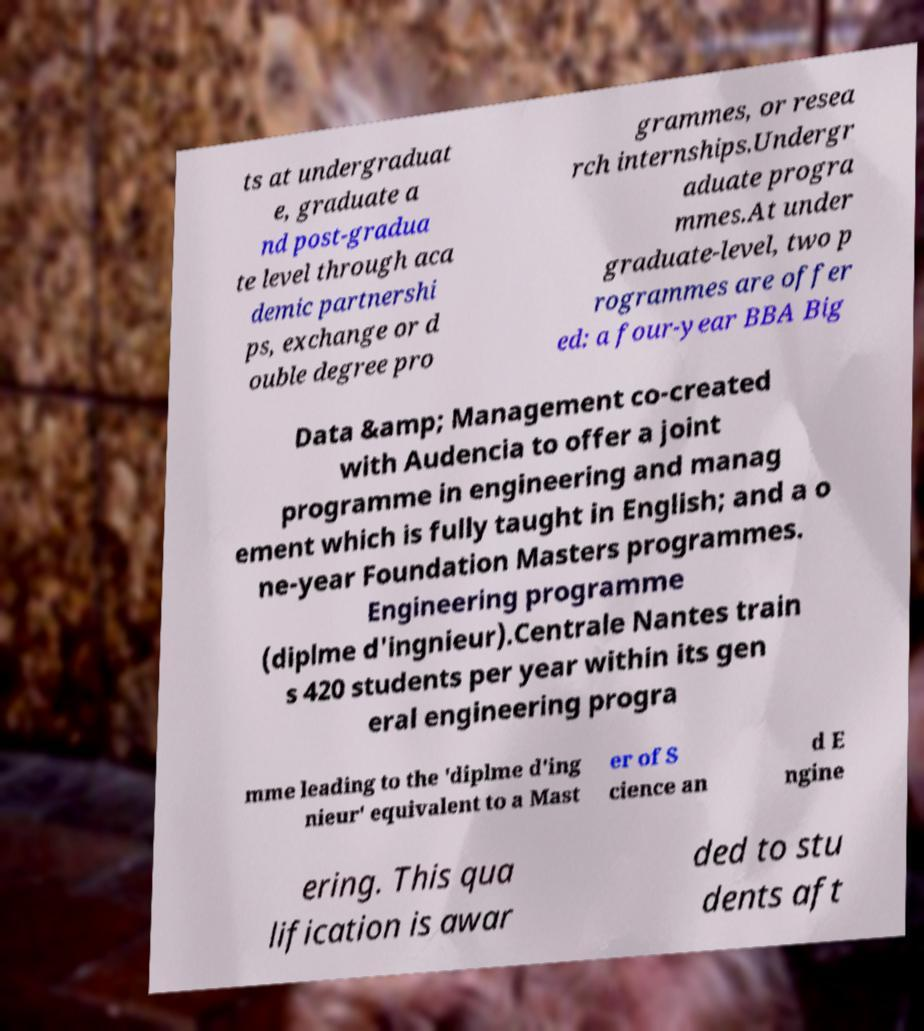Please read and relay the text visible in this image. What does it say? ts at undergraduat e, graduate a nd post-gradua te level through aca demic partnershi ps, exchange or d ouble degree pro grammes, or resea rch internships.Undergr aduate progra mmes.At under graduate-level, two p rogrammes are offer ed: a four-year BBA Big Data &amp; Management co-created with Audencia to offer a joint programme in engineering and manag ement which is fully taught in English; and a o ne-year Foundation Masters programmes. Engineering programme (diplme d'ingnieur).Centrale Nantes train s 420 students per year within its gen eral engineering progra mme leading to the 'diplme d'ing nieur' equivalent to a Mast er of S cience an d E ngine ering. This qua lification is awar ded to stu dents aft 